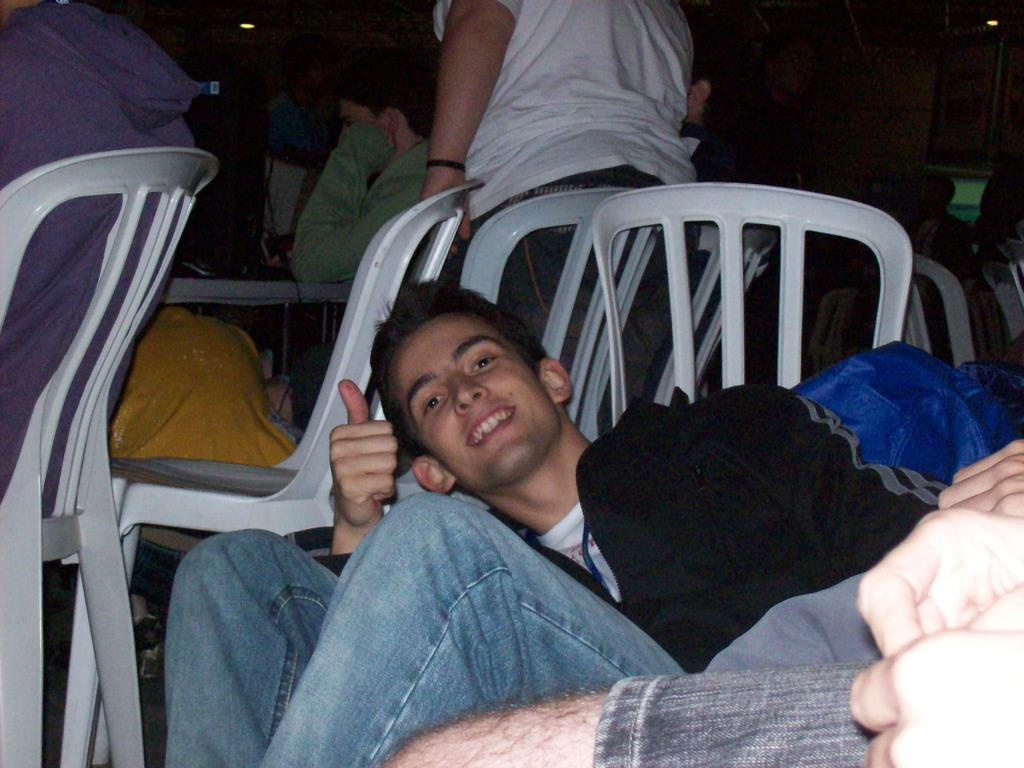What is the man in the image doing? The man is sitting in a chair in the image. What can be seen in the background of the image? There is a group of people in the background of the image. How are the people in the group positioned? Some people in the group are standing, while others are sitting in chairs. How many people are present in the image? There is at least one other person in the image besides the man sitting in the chair. What is the man learning in the image? There is no indication in the image that the man is learning anything. How does the chin of the person standing in the background change throughout the image? There is no information about the chin of any person in the image, nor is there any indication that the image is a video or has any changes over time. 